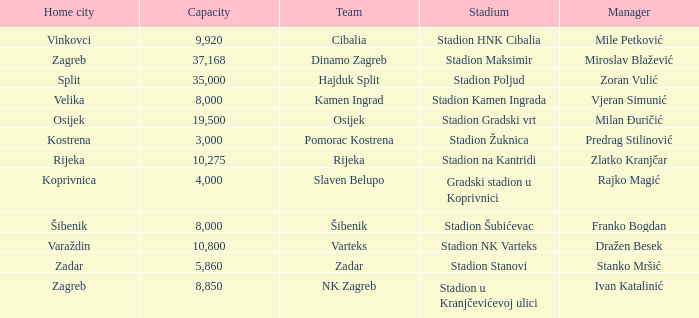What is the stadium of the NK Zagreb? Stadion u Kranjčevićevoj ulici. 